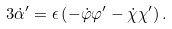Convert formula to latex. <formula><loc_0><loc_0><loc_500><loc_500>3 \dot { \alpha } ^ { \prime } = \epsilon \left ( - \dot { \varphi } \varphi ^ { \prime } - \dot { \chi } \chi ^ { \prime } \right ) .</formula> 